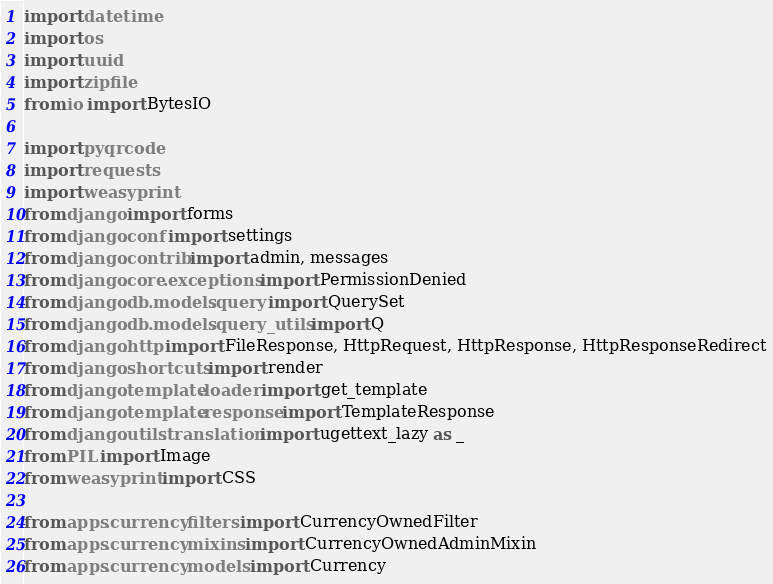Convert code to text. <code><loc_0><loc_0><loc_500><loc_500><_Python_>import datetime
import os
import uuid
import zipfile
from io import BytesIO

import pyqrcode
import requests
import weasyprint
from django import forms
from django.conf import settings
from django.contrib import admin, messages
from django.core.exceptions import PermissionDenied
from django.db.models.query import QuerySet
from django.db.models.query_utils import Q
from django.http import FileResponse, HttpRequest, HttpResponse, HttpResponseRedirect
from django.shortcuts import render
from django.template.loader import get_template
from django.template.response import TemplateResponse
from django.utils.translation import ugettext_lazy as _
from PIL import Image
from weasyprint import CSS

from apps.currency.filters import CurrencyOwnedFilter
from apps.currency.mixins import CurrencyOwnedAdminMixin
from apps.currency.models import Currency</code> 